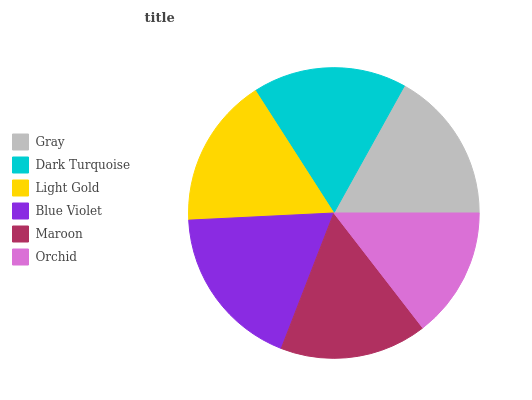Is Orchid the minimum?
Answer yes or no. Yes. Is Blue Violet the maximum?
Answer yes or no. Yes. Is Dark Turquoise the minimum?
Answer yes or no. No. Is Dark Turquoise the maximum?
Answer yes or no. No. Is Dark Turquoise greater than Gray?
Answer yes or no. Yes. Is Gray less than Dark Turquoise?
Answer yes or no. Yes. Is Gray greater than Dark Turquoise?
Answer yes or no. No. Is Dark Turquoise less than Gray?
Answer yes or no. No. Is Gray the high median?
Answer yes or no. Yes. Is Light Gold the low median?
Answer yes or no. Yes. Is Maroon the high median?
Answer yes or no. No. Is Blue Violet the low median?
Answer yes or no. No. 